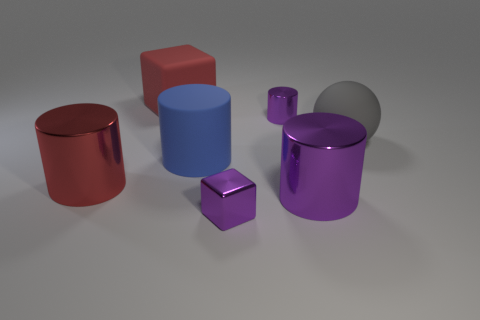What is the material of the large object that is left of the matte sphere and behind the blue matte cylinder?
Provide a succinct answer. Rubber. There is a object to the left of the red matte block to the left of the small shiny object that is in front of the large rubber ball; what color is it?
Ensure brevity in your answer.  Red. There is a cube that is the same size as the matte ball; what is its color?
Your answer should be very brief. Red. Do the big ball and the tiny thing in front of the big blue rubber object have the same color?
Offer a very short reply. No. There is a tiny object to the right of the cube that is in front of the large red rubber cube; what is it made of?
Your response must be concise. Metal. How many cylinders are in front of the blue matte object and left of the metallic block?
Offer a terse response. 1. How many other objects are there of the same size as the blue rubber cylinder?
Give a very brief answer. 4. Does the red object that is behind the blue rubber cylinder have the same shape as the shiny thing that is behind the gray thing?
Ensure brevity in your answer.  No. There is a blue rubber cylinder; are there any large matte cylinders behind it?
Provide a succinct answer. No. The other small metallic thing that is the same shape as the red shiny object is what color?
Ensure brevity in your answer.  Purple. 